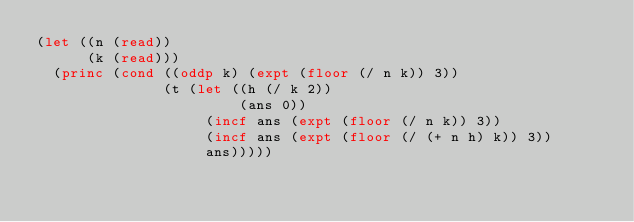<code> <loc_0><loc_0><loc_500><loc_500><_Lisp_>(let ((n (read))
      (k (read)))
  (princ (cond ((oddp k) (expt (floor (/ n k)) 3))
               (t (let ((h (/ k 2))
                        (ans 0))
                    (incf ans (expt (floor (/ n k)) 3))
                    (incf ans (expt (floor (/ (+ n h) k)) 3))
                    ans)))))
</code> 